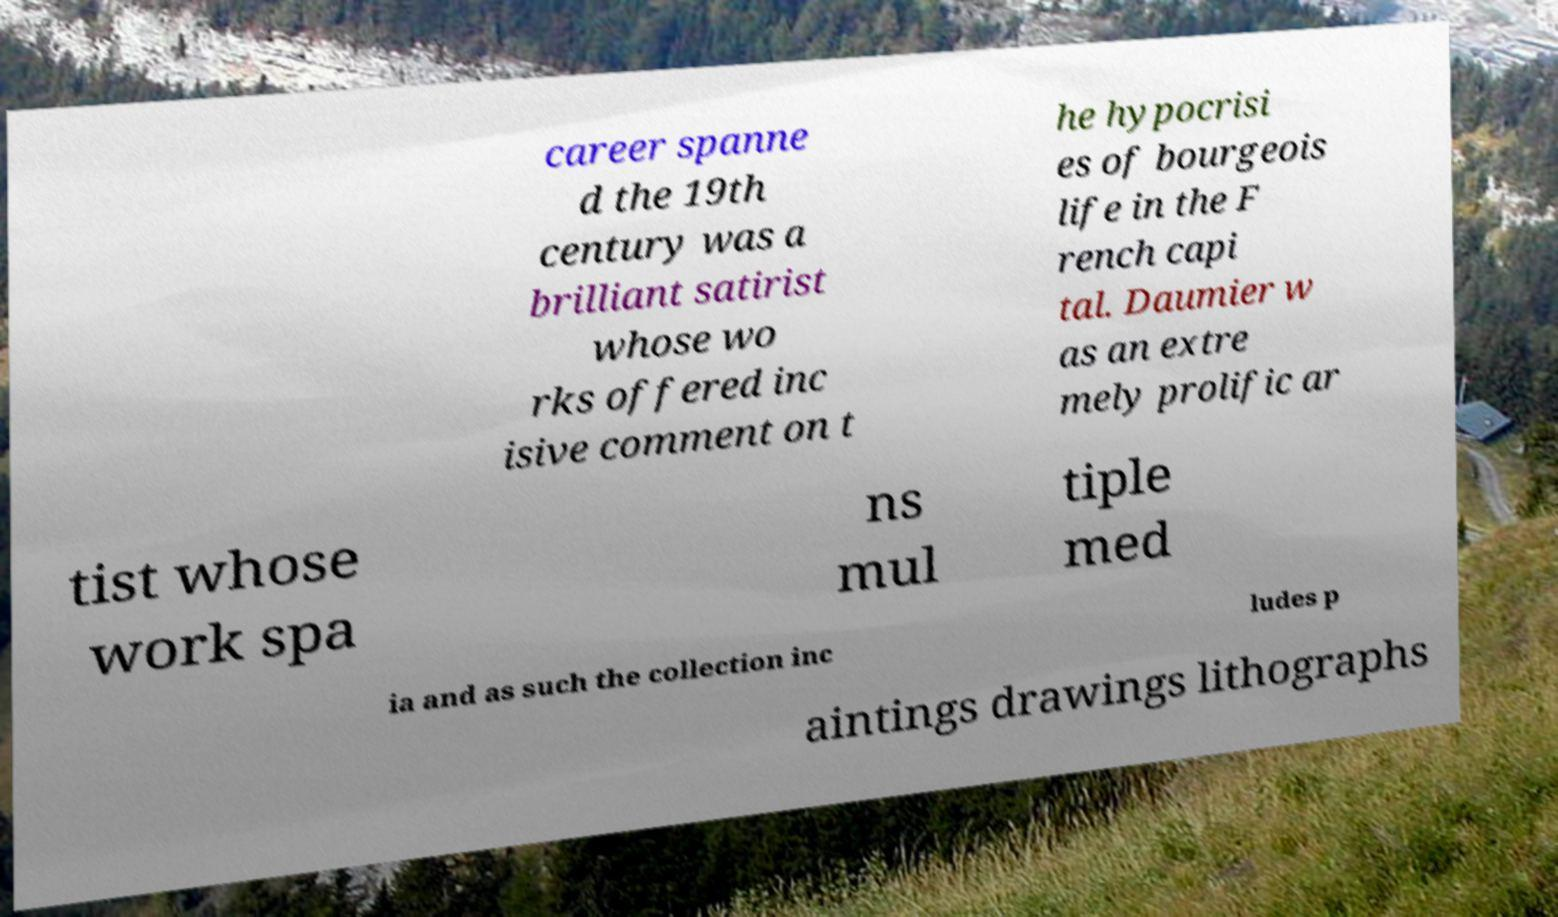What messages or text are displayed in this image? I need them in a readable, typed format. career spanne d the 19th century was a brilliant satirist whose wo rks offered inc isive comment on t he hypocrisi es of bourgeois life in the F rench capi tal. Daumier w as an extre mely prolific ar tist whose work spa ns mul tiple med ia and as such the collection inc ludes p aintings drawings lithographs 